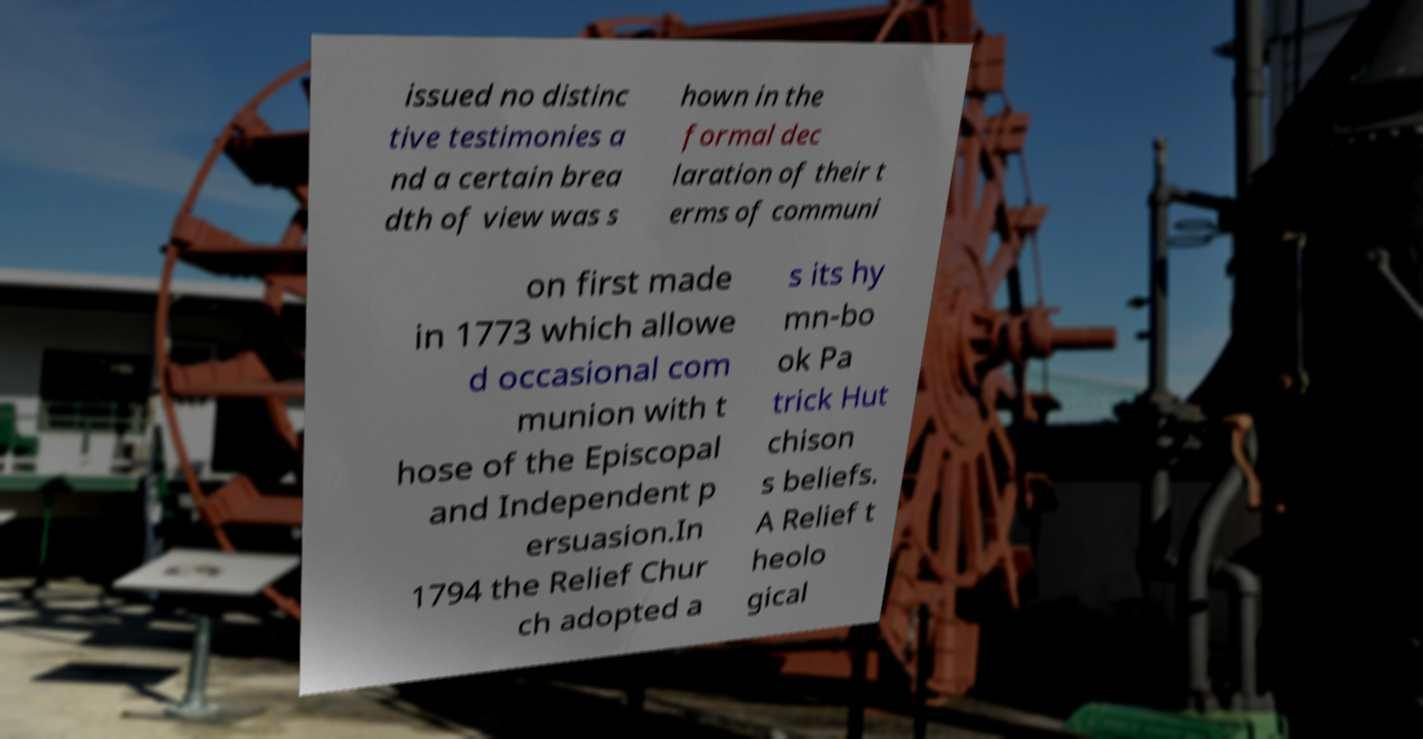There's text embedded in this image that I need extracted. Can you transcribe it verbatim? issued no distinc tive testimonies a nd a certain brea dth of view was s hown in the formal dec laration of their t erms of communi on first made in 1773 which allowe d occasional com munion with t hose of the Episcopal and Independent p ersuasion.In 1794 the Relief Chur ch adopted a s its hy mn-bo ok Pa trick Hut chison s beliefs. A Relief t heolo gical 